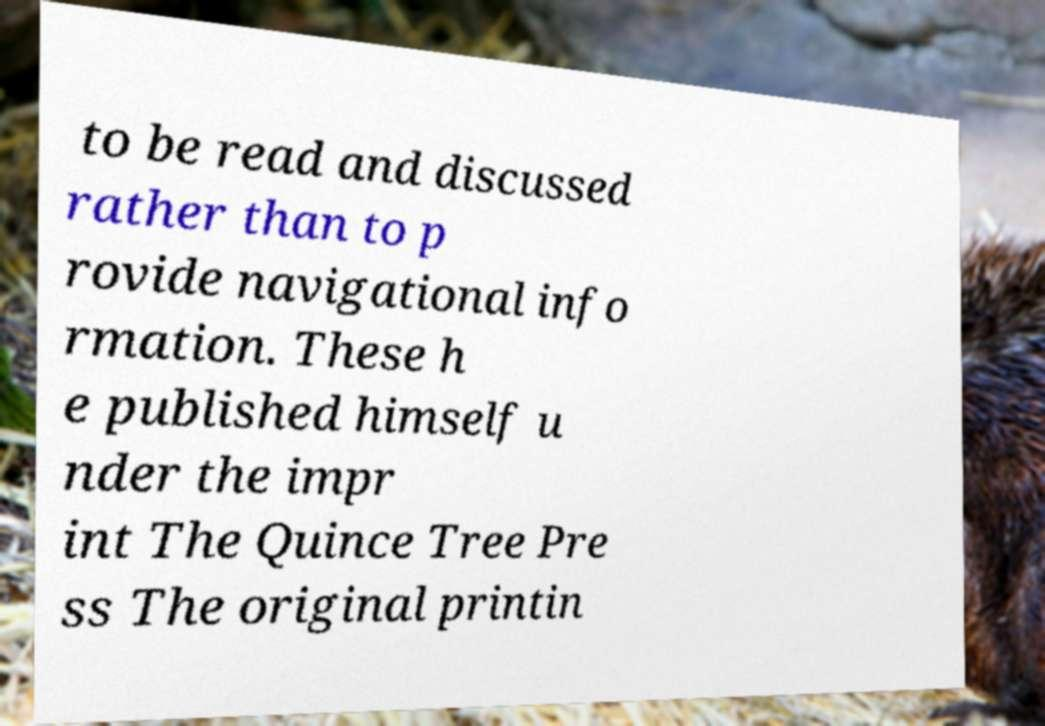Can you accurately transcribe the text from the provided image for me? to be read and discussed rather than to p rovide navigational info rmation. These h e published himself u nder the impr int The Quince Tree Pre ss The original printin 